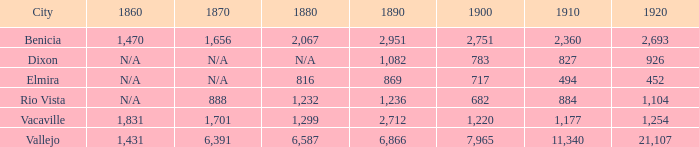When 1890 is more than 1,236, 1910 is under 1,177, and the city is vacaville, what is the value for 1920? None. 